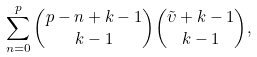Convert formula to latex. <formula><loc_0><loc_0><loc_500><loc_500>\sum _ { n = 0 } ^ { p } { { p - n + k - 1 } \choose { k - 1 } } { { \tilde { \upsilon } + k - 1 } \choose { k - 1 } } ,</formula> 